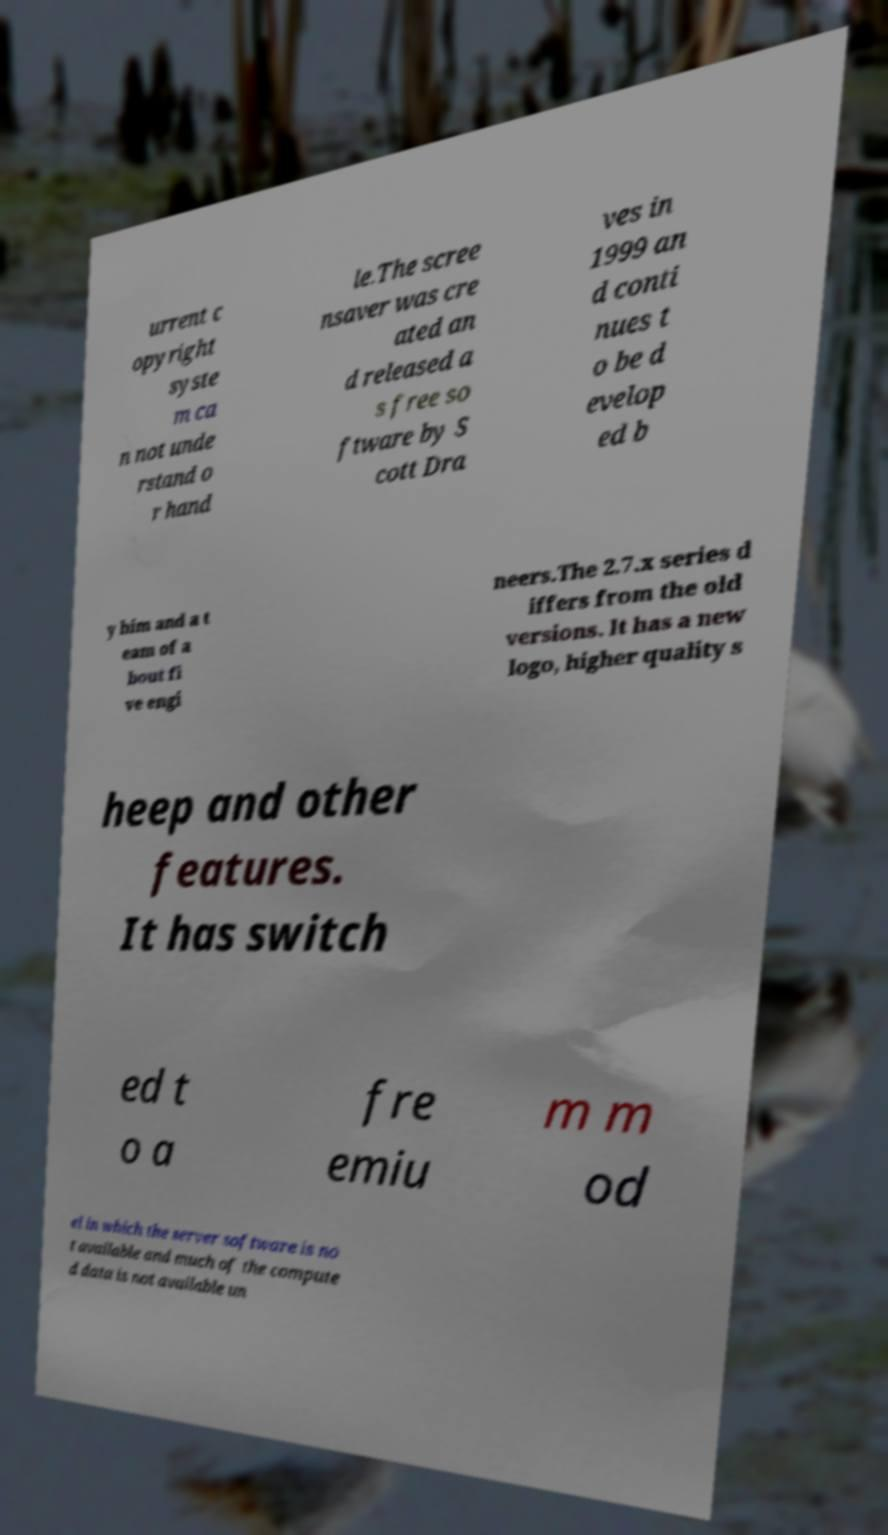Can you read and provide the text displayed in the image?This photo seems to have some interesting text. Can you extract and type it out for me? urrent c opyright syste m ca n not unde rstand o r hand le.The scree nsaver was cre ated an d released a s free so ftware by S cott Dra ves in 1999 an d conti nues t o be d evelop ed b y him and a t eam of a bout fi ve engi neers.The 2.7.x series d iffers from the old versions. It has a new logo, higher quality s heep and other features. It has switch ed t o a fre emiu m m od el in which the server software is no t available and much of the compute d data is not available un 